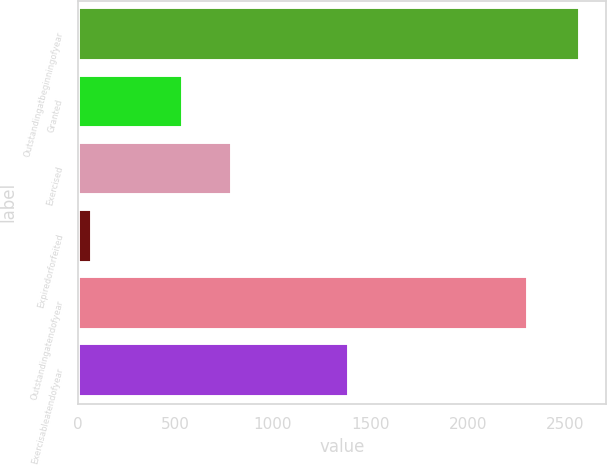<chart> <loc_0><loc_0><loc_500><loc_500><bar_chart><fcel>Outstandingatbeginningofyear<fcel>Granted<fcel>Exercised<fcel>Expiredorforfeited<fcel>Outstandingatendofyear<fcel>Exercisableatendofyear<nl><fcel>2579<fcel>538<fcel>788.8<fcel>71<fcel>2310<fcel>1391<nl></chart> 